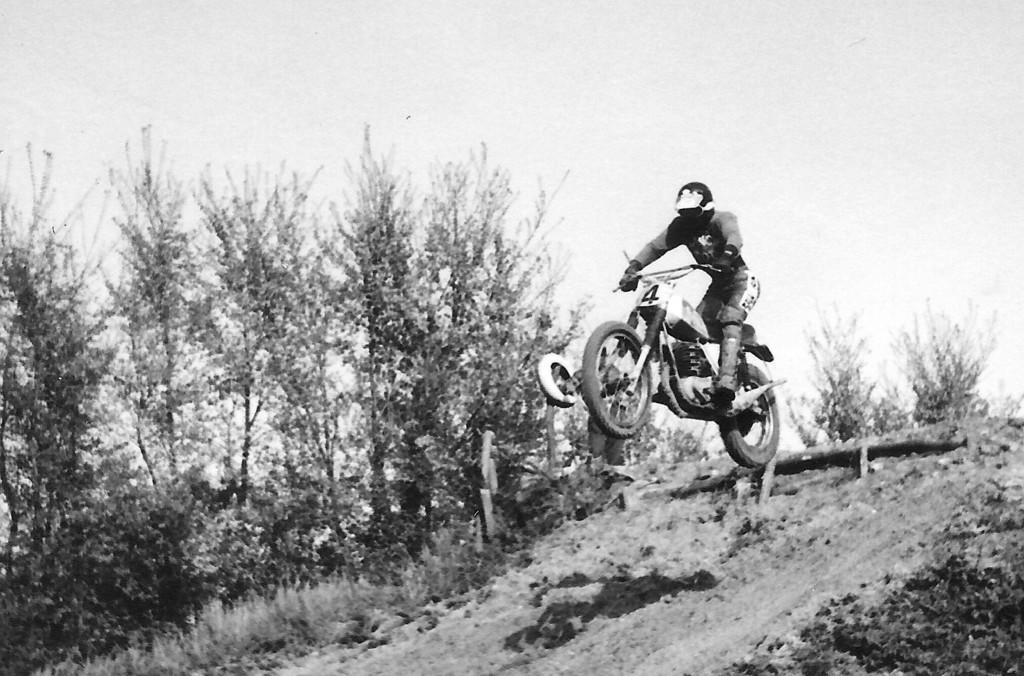Could you give a brief overview of what you see in this image? In this image a person is in air along with the bike. He is wearing helmet. Background there are few plants and trees on the land. Top of image there is sky. 